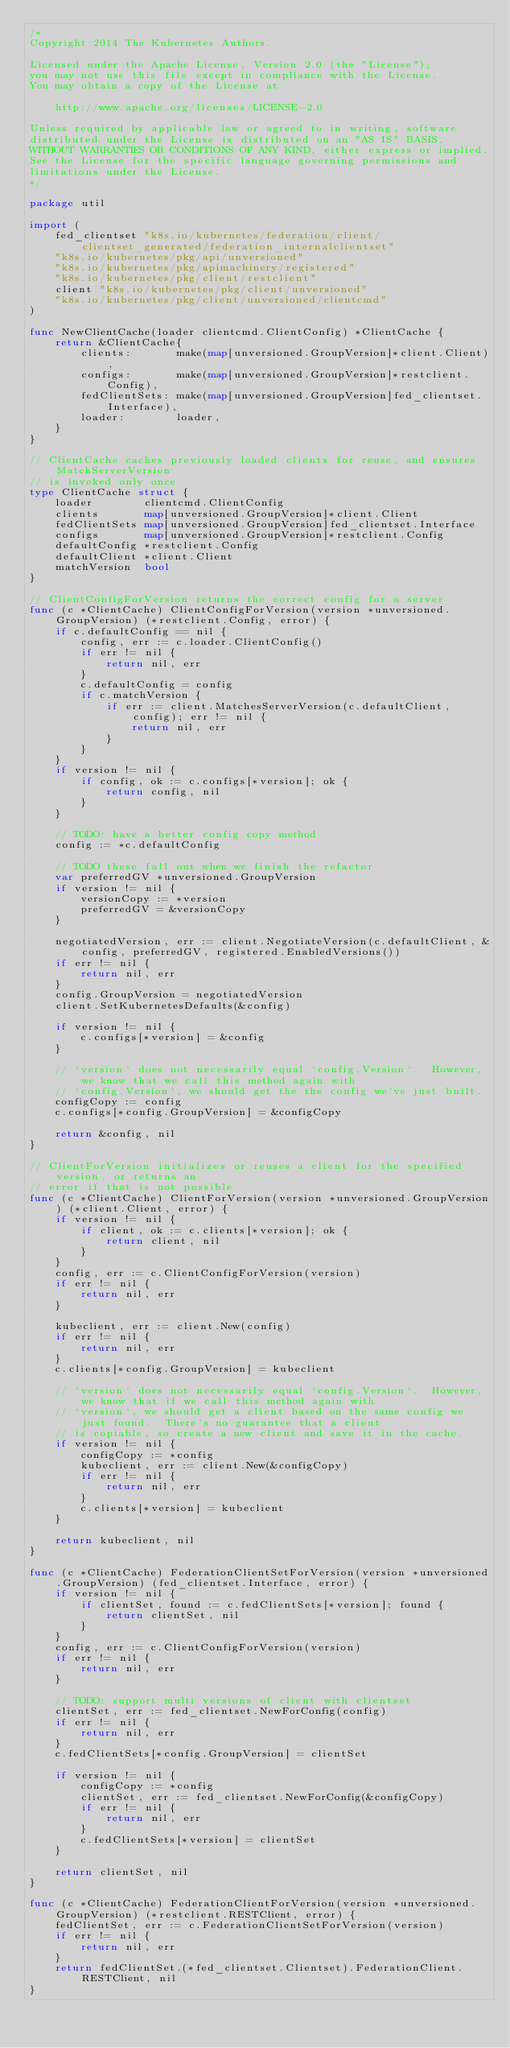<code> <loc_0><loc_0><loc_500><loc_500><_Go_>/*
Copyright 2014 The Kubernetes Authors.

Licensed under the Apache License, Version 2.0 (the "License");
you may not use this file except in compliance with the License.
You may obtain a copy of the License at

    http://www.apache.org/licenses/LICENSE-2.0

Unless required by applicable law or agreed to in writing, software
distributed under the License is distributed on an "AS IS" BASIS,
WITHOUT WARRANTIES OR CONDITIONS OF ANY KIND, either express or implied.
See the License for the specific language governing permissions and
limitations under the License.
*/

package util

import (
	fed_clientset "k8s.io/kubernetes/federation/client/clientset_generated/federation_internalclientset"
	"k8s.io/kubernetes/pkg/api/unversioned"
	"k8s.io/kubernetes/pkg/apimachinery/registered"
	"k8s.io/kubernetes/pkg/client/restclient"
	client "k8s.io/kubernetes/pkg/client/unversioned"
	"k8s.io/kubernetes/pkg/client/unversioned/clientcmd"
)

func NewClientCache(loader clientcmd.ClientConfig) *ClientCache {
	return &ClientCache{
		clients:       make(map[unversioned.GroupVersion]*client.Client),
		configs:       make(map[unversioned.GroupVersion]*restclient.Config),
		fedClientSets: make(map[unversioned.GroupVersion]fed_clientset.Interface),
		loader:        loader,
	}
}

// ClientCache caches previously loaded clients for reuse, and ensures MatchServerVersion
// is invoked only once
type ClientCache struct {
	loader        clientcmd.ClientConfig
	clients       map[unversioned.GroupVersion]*client.Client
	fedClientSets map[unversioned.GroupVersion]fed_clientset.Interface
	configs       map[unversioned.GroupVersion]*restclient.Config
	defaultConfig *restclient.Config
	defaultClient *client.Client
	matchVersion  bool
}

// ClientConfigForVersion returns the correct config for a server
func (c *ClientCache) ClientConfigForVersion(version *unversioned.GroupVersion) (*restclient.Config, error) {
	if c.defaultConfig == nil {
		config, err := c.loader.ClientConfig()
		if err != nil {
			return nil, err
		}
		c.defaultConfig = config
		if c.matchVersion {
			if err := client.MatchesServerVersion(c.defaultClient, config); err != nil {
				return nil, err
			}
		}
	}
	if version != nil {
		if config, ok := c.configs[*version]; ok {
			return config, nil
		}
	}

	// TODO: have a better config copy method
	config := *c.defaultConfig

	// TODO these fall out when we finish the refactor
	var preferredGV *unversioned.GroupVersion
	if version != nil {
		versionCopy := *version
		preferredGV = &versionCopy
	}

	negotiatedVersion, err := client.NegotiateVersion(c.defaultClient, &config, preferredGV, registered.EnabledVersions())
	if err != nil {
		return nil, err
	}
	config.GroupVersion = negotiatedVersion
	client.SetKubernetesDefaults(&config)

	if version != nil {
		c.configs[*version] = &config
	}

	// `version` does not necessarily equal `config.Version`.  However, we know that we call this method again with
	// `config.Version`, we should get the the config we've just built.
	configCopy := config
	c.configs[*config.GroupVersion] = &configCopy

	return &config, nil
}

// ClientForVersion initializes or reuses a client for the specified version, or returns an
// error if that is not possible
func (c *ClientCache) ClientForVersion(version *unversioned.GroupVersion) (*client.Client, error) {
	if version != nil {
		if client, ok := c.clients[*version]; ok {
			return client, nil
		}
	}
	config, err := c.ClientConfigForVersion(version)
	if err != nil {
		return nil, err
	}

	kubeclient, err := client.New(config)
	if err != nil {
		return nil, err
	}
	c.clients[*config.GroupVersion] = kubeclient

	// `version` does not necessarily equal `config.Version`.  However, we know that if we call this method again with
	// `version`, we should get a client based on the same config we just found.  There's no guarantee that a client
	// is copiable, so create a new client and save it in the cache.
	if version != nil {
		configCopy := *config
		kubeclient, err := client.New(&configCopy)
		if err != nil {
			return nil, err
		}
		c.clients[*version] = kubeclient
	}

	return kubeclient, nil
}

func (c *ClientCache) FederationClientSetForVersion(version *unversioned.GroupVersion) (fed_clientset.Interface, error) {
	if version != nil {
		if clientSet, found := c.fedClientSets[*version]; found {
			return clientSet, nil
		}
	}
	config, err := c.ClientConfigForVersion(version)
	if err != nil {
		return nil, err
	}

	// TODO: support multi versions of client with clientset
	clientSet, err := fed_clientset.NewForConfig(config)
	if err != nil {
		return nil, err
	}
	c.fedClientSets[*config.GroupVersion] = clientSet

	if version != nil {
		configCopy := *config
		clientSet, err := fed_clientset.NewForConfig(&configCopy)
		if err != nil {
			return nil, err
		}
		c.fedClientSets[*version] = clientSet
	}

	return clientSet, nil
}

func (c *ClientCache) FederationClientForVersion(version *unversioned.GroupVersion) (*restclient.RESTClient, error) {
	fedClientSet, err := c.FederationClientSetForVersion(version)
	if err != nil {
		return nil, err
	}
	return fedClientSet.(*fed_clientset.Clientset).FederationClient.RESTClient, nil
}
</code> 